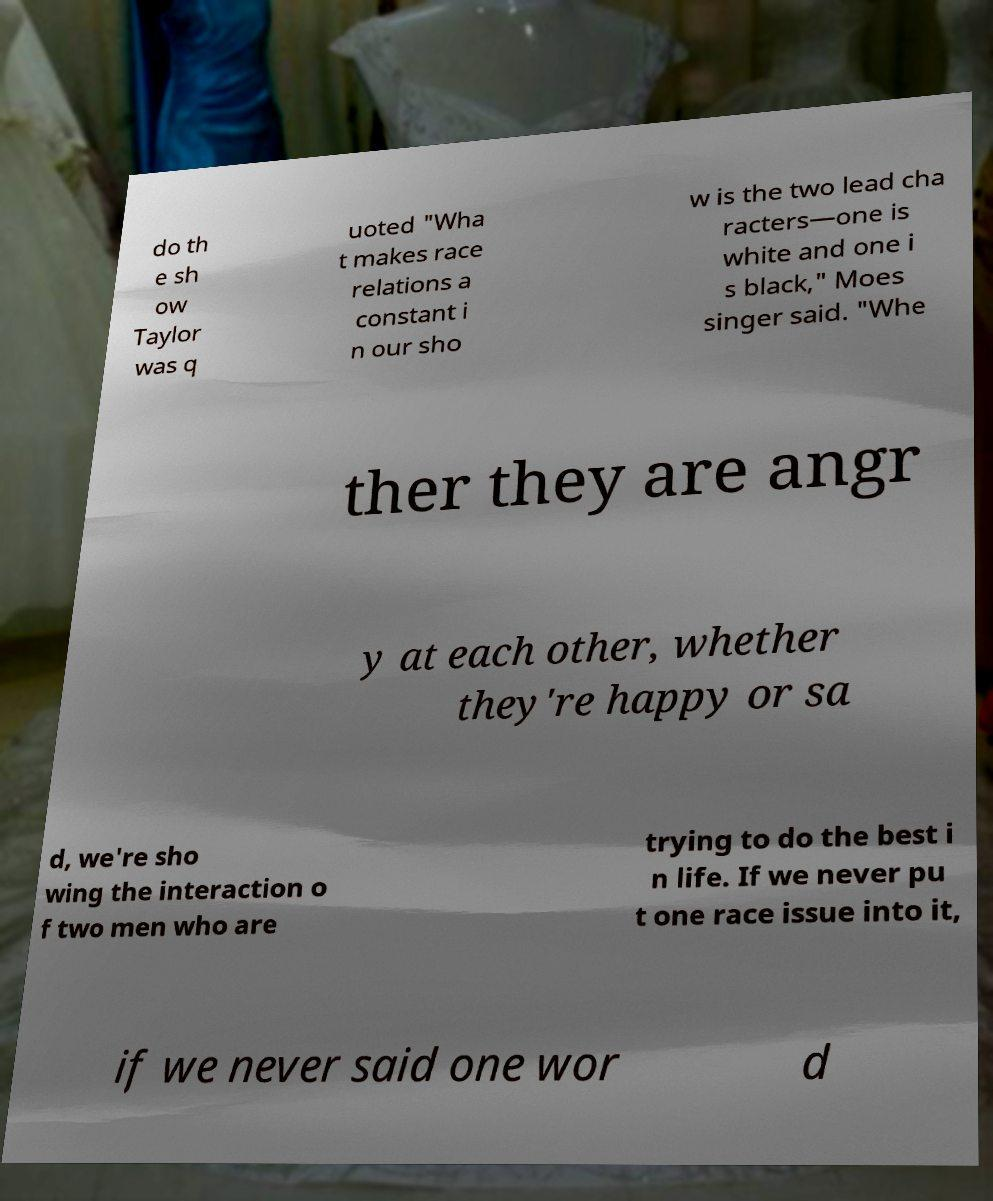Please read and relay the text visible in this image. What does it say? do th e sh ow Taylor was q uoted "Wha t makes race relations a constant i n our sho w is the two lead cha racters—one is white and one i s black," Moes singer said. "Whe ther they are angr y at each other, whether they're happy or sa d, we're sho wing the interaction o f two men who are trying to do the best i n life. If we never pu t one race issue into it, if we never said one wor d 